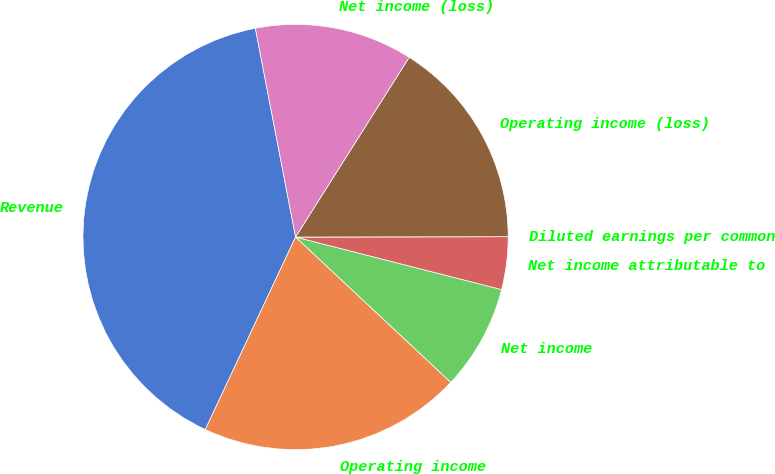<chart> <loc_0><loc_0><loc_500><loc_500><pie_chart><fcel>Revenue<fcel>Operating income<fcel>Net income<fcel>Net income attributable to<fcel>Diluted earnings per common<fcel>Operating income (loss)<fcel>Net income (loss)<nl><fcel>39.99%<fcel>20.0%<fcel>8.0%<fcel>4.0%<fcel>0.0%<fcel>16.0%<fcel>12.0%<nl></chart> 